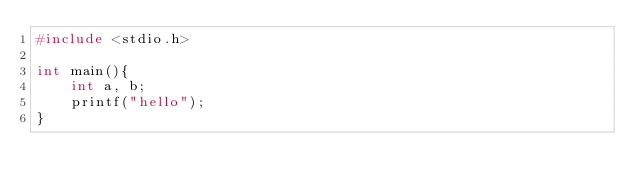Convert code to text. <code><loc_0><loc_0><loc_500><loc_500><_C_>#include <stdio.h>

int main(){
	int a, b;
	printf("hello");
}</code> 